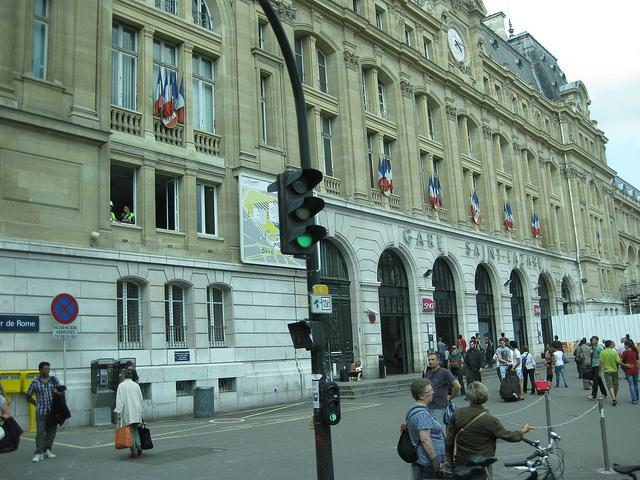What actress was born in this country? juliette binoche 